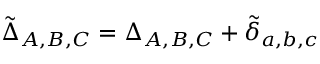Convert formula to latex. <formula><loc_0><loc_0><loc_500><loc_500>\tilde { \Delta } _ { A , B , C } = \Delta _ { A , B , C } + \tilde { \delta } _ { a , b , c }</formula> 